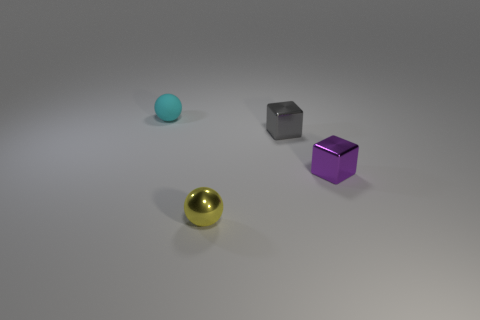What color is the small metal ball?
Keep it short and to the point. Yellow. Is the color of the tiny matte ball the same as the tiny sphere that is to the right of the cyan rubber thing?
Your answer should be compact. No. Is there a cyan thing of the same size as the purple object?
Keep it short and to the point. Yes. What material is the ball behind the yellow metallic thing?
Offer a very short reply. Rubber. Are there an equal number of rubber things that are in front of the tiny gray cube and tiny balls to the right of the tiny cyan rubber ball?
Provide a succinct answer. No. Does the thing that is behind the tiny gray metallic object have the same size as the sphere that is on the right side of the cyan rubber object?
Make the answer very short. Yes. Are there more purple metal objects that are behind the small gray object than cyan spheres?
Give a very brief answer. No. Is the small purple object the same shape as the small gray metal thing?
Make the answer very short. Yes. How many small brown objects have the same material as the gray block?
Your response must be concise. 0. The other thing that is the same shape as the small purple shiny object is what size?
Provide a short and direct response. Small. 